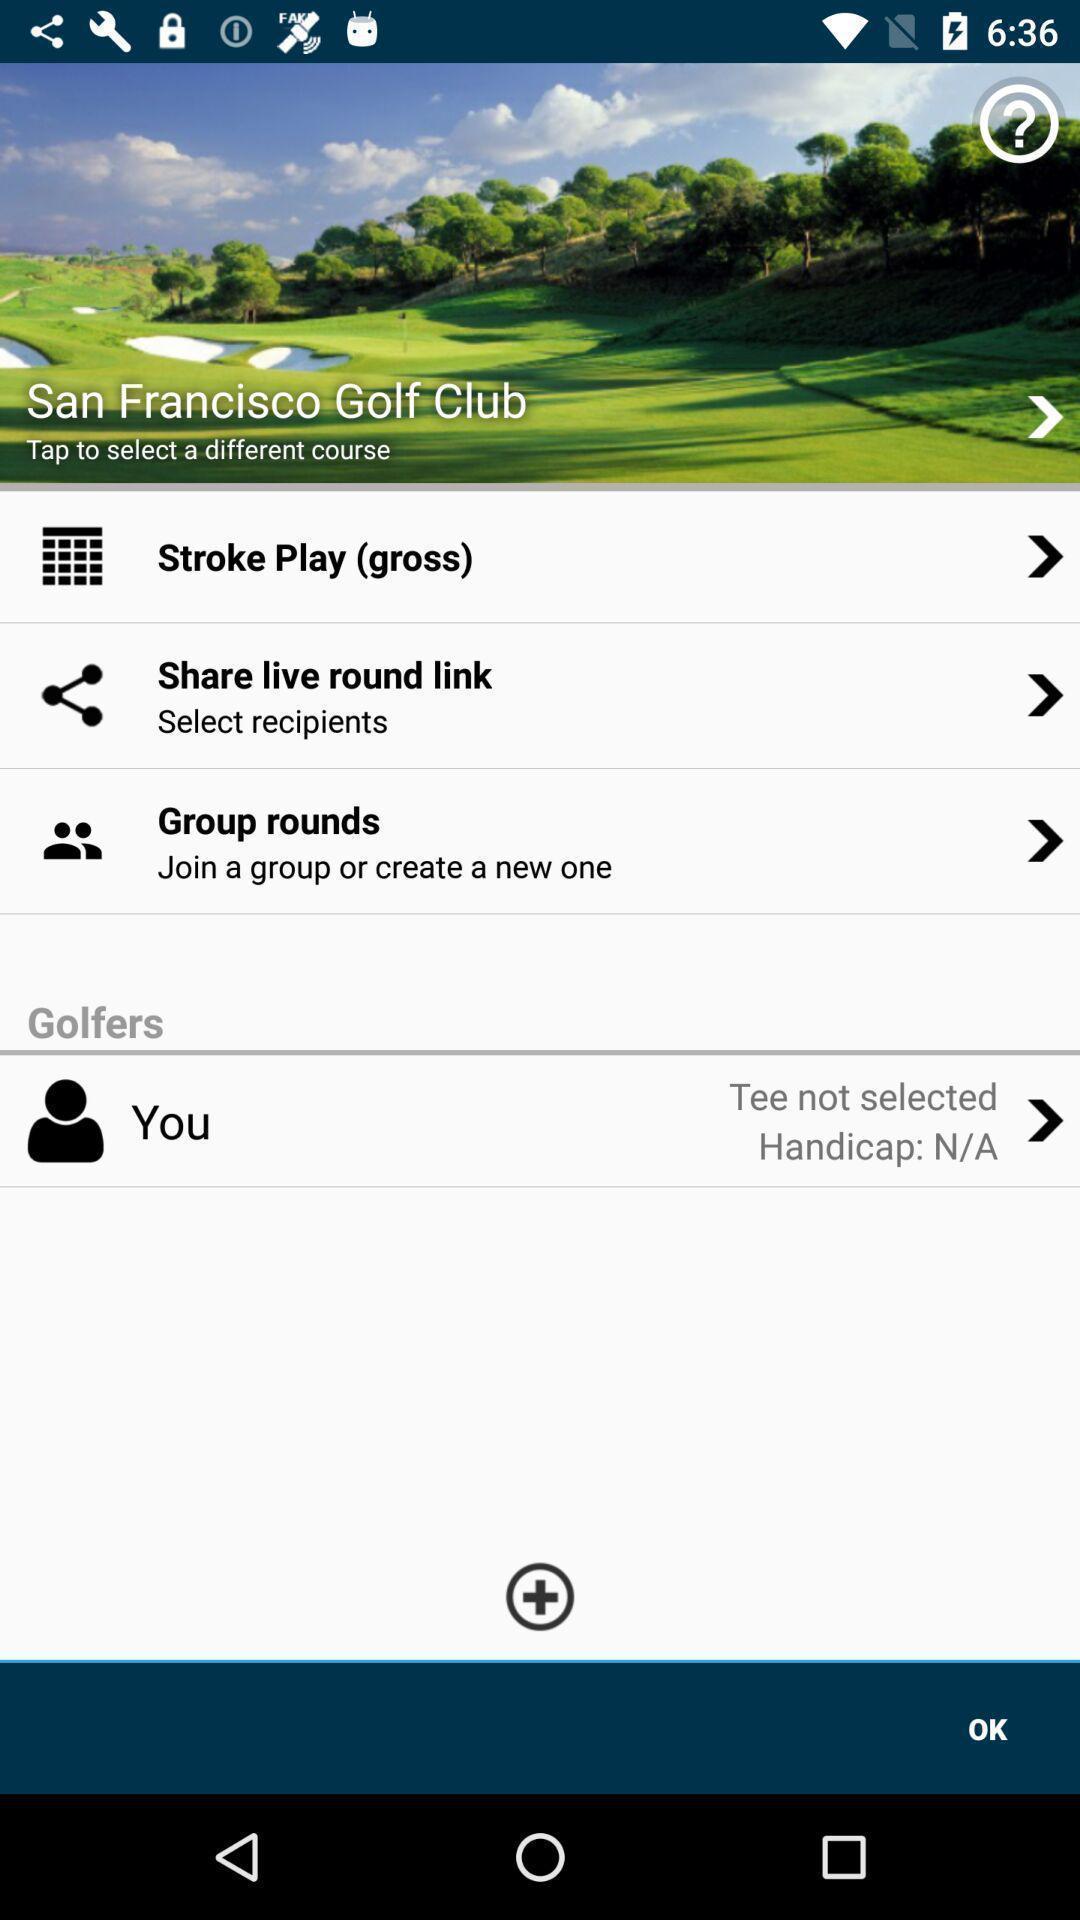Describe the visual elements of this screenshot. Tap the image to select a different courses. 